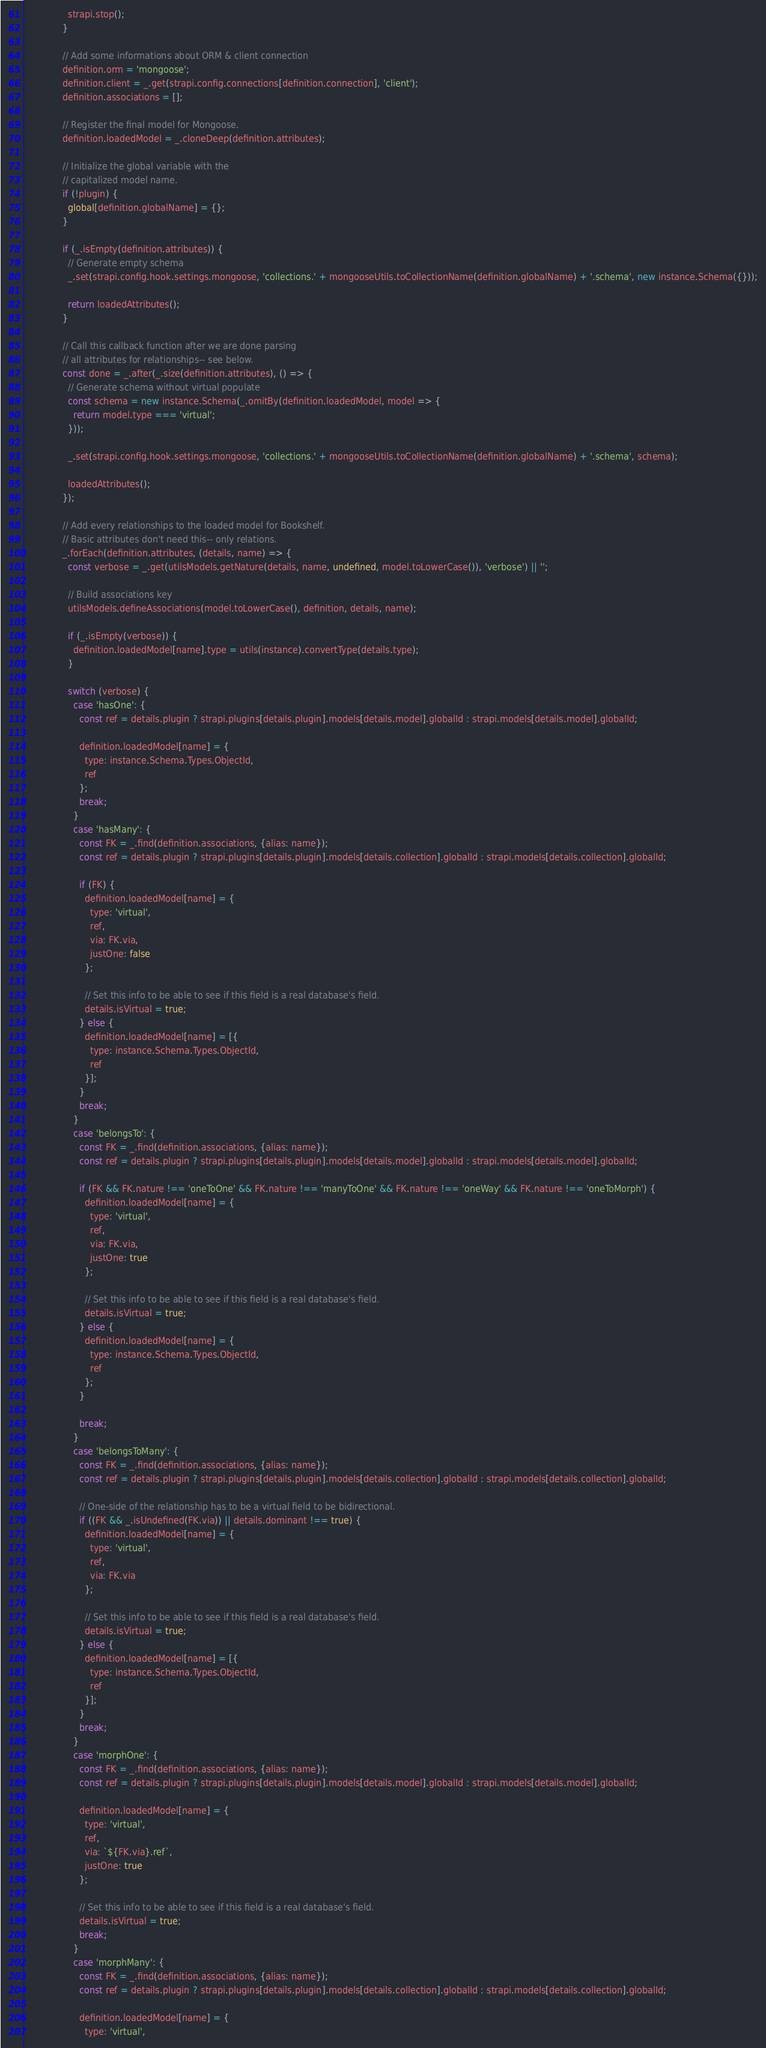Convert code to text. <code><loc_0><loc_0><loc_500><loc_500><_JavaScript_>                strapi.stop();
              }

              // Add some informations about ORM & client connection
              definition.orm = 'mongoose';
              definition.client = _.get(strapi.config.connections[definition.connection], 'client');
              definition.associations = [];

              // Register the final model for Mongoose.
              definition.loadedModel = _.cloneDeep(definition.attributes);

              // Initialize the global variable with the
              // capitalized model name.
              if (!plugin) {
                global[definition.globalName] = {};
              }

              if (_.isEmpty(definition.attributes)) {
                // Generate empty schema
                _.set(strapi.config.hook.settings.mongoose, 'collections.' + mongooseUtils.toCollectionName(definition.globalName) + '.schema', new instance.Schema({}));

                return loadedAttributes();
              }

              // Call this callback function after we are done parsing
              // all attributes for relationships-- see below.
              const done = _.after(_.size(definition.attributes), () => {
                // Generate schema without virtual populate
                const schema = new instance.Schema(_.omitBy(definition.loadedModel, model => {
                  return model.type === 'virtual';
                }));

                _.set(strapi.config.hook.settings.mongoose, 'collections.' + mongooseUtils.toCollectionName(definition.globalName) + '.schema', schema);

                loadedAttributes();
              });

              // Add every relationships to the loaded model for Bookshelf.
              // Basic attributes don't need this-- only relations.
              _.forEach(definition.attributes, (details, name) => {
                const verbose = _.get(utilsModels.getNature(details, name, undefined, model.toLowerCase()), 'verbose') || '';

                // Build associations key
                utilsModels.defineAssociations(model.toLowerCase(), definition, details, name);

                if (_.isEmpty(verbose)) {
                  definition.loadedModel[name].type = utils(instance).convertType(details.type);
                }

                switch (verbose) {
                  case 'hasOne': {
                    const ref = details.plugin ? strapi.plugins[details.plugin].models[details.model].globalId : strapi.models[details.model].globalId;

                    definition.loadedModel[name] = {
                      type: instance.Schema.Types.ObjectId,
                      ref
                    };
                    break;
                  }
                  case 'hasMany': {
                    const FK = _.find(definition.associations, {alias: name});
                    const ref = details.plugin ? strapi.plugins[details.plugin].models[details.collection].globalId : strapi.models[details.collection].globalId;

                    if (FK) {
                      definition.loadedModel[name] = {
                        type: 'virtual',
                        ref,
                        via: FK.via,
                        justOne: false
                      };

                      // Set this info to be able to see if this field is a real database's field.
                      details.isVirtual = true;
                    } else {
                      definition.loadedModel[name] = [{
                        type: instance.Schema.Types.ObjectId,
                        ref
                      }];
                    }
                    break;
                  }
                  case 'belongsTo': {
                    const FK = _.find(definition.associations, {alias: name});
                    const ref = details.plugin ? strapi.plugins[details.plugin].models[details.model].globalId : strapi.models[details.model].globalId;

                    if (FK && FK.nature !== 'oneToOne' && FK.nature !== 'manyToOne' && FK.nature !== 'oneWay' && FK.nature !== 'oneToMorph') {
                      definition.loadedModel[name] = {
                        type: 'virtual',
                        ref,
                        via: FK.via,
                        justOne: true
                      };

                      // Set this info to be able to see if this field is a real database's field.
                      details.isVirtual = true;
                    } else {
                      definition.loadedModel[name] = {
                        type: instance.Schema.Types.ObjectId,
                        ref
                      };
                    }

                    break;
                  }
                  case 'belongsToMany': {
                    const FK = _.find(definition.associations, {alias: name});
                    const ref = details.plugin ? strapi.plugins[details.plugin].models[details.collection].globalId : strapi.models[details.collection].globalId;

                    // One-side of the relationship has to be a virtual field to be bidirectional.
                    if ((FK && _.isUndefined(FK.via)) || details.dominant !== true) {
                      definition.loadedModel[name] = {
                        type: 'virtual',
                        ref,
                        via: FK.via
                      };

                      // Set this info to be able to see if this field is a real database's field.
                      details.isVirtual = true;
                    } else {
                      definition.loadedModel[name] = [{
                        type: instance.Schema.Types.ObjectId,
                        ref
                      }];
                    }
                    break;
                  }
                  case 'morphOne': {
                    const FK = _.find(definition.associations, {alias: name});
                    const ref = details.plugin ? strapi.plugins[details.plugin].models[details.model].globalId : strapi.models[details.model].globalId;

                    definition.loadedModel[name] = {
                      type: 'virtual',
                      ref,
                      via: `${FK.via}.ref`,
                      justOne: true
                    };

                    // Set this info to be able to see if this field is a real database's field.
                    details.isVirtual = true;
                    break;
                  }
                  case 'morphMany': {
                    const FK = _.find(definition.associations, {alias: name});
                    const ref = details.plugin ? strapi.plugins[details.plugin].models[details.collection].globalId : strapi.models[details.collection].globalId;

                    definition.loadedModel[name] = {
                      type: 'virtual',</code> 